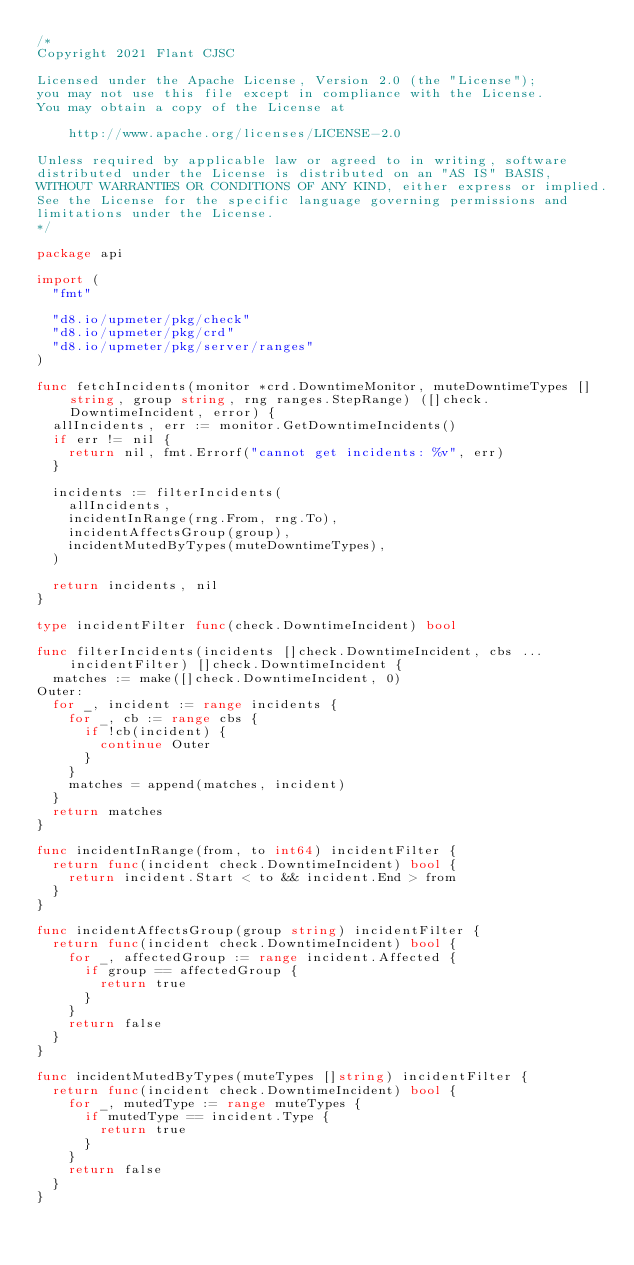<code> <loc_0><loc_0><loc_500><loc_500><_Go_>/*
Copyright 2021 Flant CJSC

Licensed under the Apache License, Version 2.0 (the "License");
you may not use this file except in compliance with the License.
You may obtain a copy of the License at

    http://www.apache.org/licenses/LICENSE-2.0

Unless required by applicable law or agreed to in writing, software
distributed under the License is distributed on an "AS IS" BASIS,
WITHOUT WARRANTIES OR CONDITIONS OF ANY KIND, either express or implied.
See the License for the specific language governing permissions and
limitations under the License.
*/

package api

import (
	"fmt"

	"d8.io/upmeter/pkg/check"
	"d8.io/upmeter/pkg/crd"
	"d8.io/upmeter/pkg/server/ranges"
)

func fetchIncidents(monitor *crd.DowntimeMonitor, muteDowntimeTypes []string, group string, rng ranges.StepRange) ([]check.DowntimeIncident, error) {
	allIncidents, err := monitor.GetDowntimeIncidents()
	if err != nil {
		return nil, fmt.Errorf("cannot get incidents: %v", err)
	}

	incidents := filterIncidents(
		allIncidents,
		incidentInRange(rng.From, rng.To),
		incidentAffectsGroup(group),
		incidentMutedByTypes(muteDowntimeTypes),
	)

	return incidents, nil
}

type incidentFilter func(check.DowntimeIncident) bool

func filterIncidents(incidents []check.DowntimeIncident, cbs ...incidentFilter) []check.DowntimeIncident {
	matches := make([]check.DowntimeIncident, 0)
Outer:
	for _, incident := range incidents {
		for _, cb := range cbs {
			if !cb(incident) {
				continue Outer
			}
		}
		matches = append(matches, incident)
	}
	return matches
}

func incidentInRange(from, to int64) incidentFilter {
	return func(incident check.DowntimeIncident) bool {
		return incident.Start < to && incident.End > from
	}
}

func incidentAffectsGroup(group string) incidentFilter {
	return func(incident check.DowntimeIncident) bool {
		for _, affectedGroup := range incident.Affected {
			if group == affectedGroup {
				return true
			}
		}
		return false
	}
}

func incidentMutedByTypes(muteTypes []string) incidentFilter {
	return func(incident check.DowntimeIncident) bool {
		for _, mutedType := range muteTypes {
			if mutedType == incident.Type {
				return true
			}
		}
		return false
	}
}
</code> 